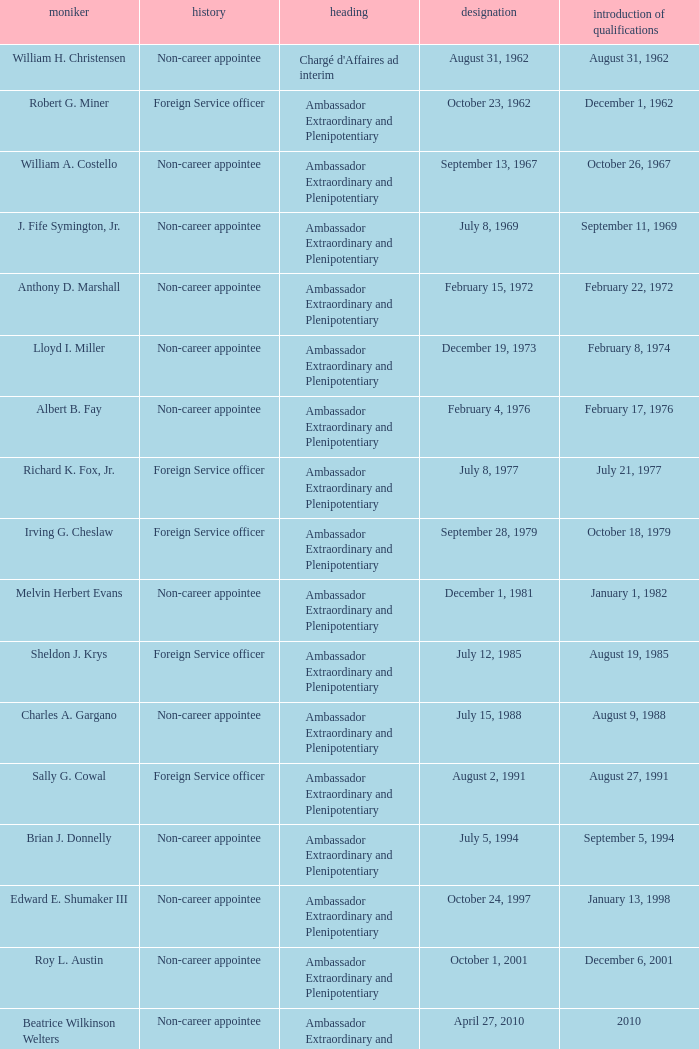When did Robert G. Miner present his credentials? December 1, 1962. 